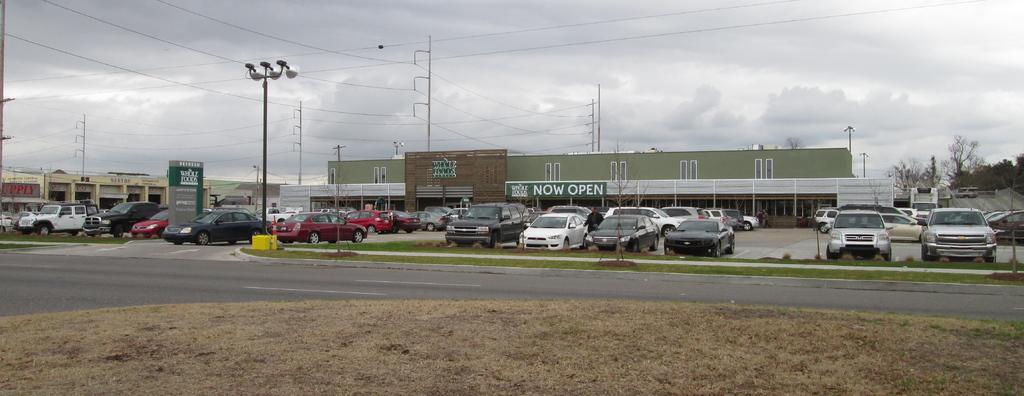<image>
Render a clear and concise summary of the photo. A whole Foods grocery store has a full parking lot on a cloudy day 